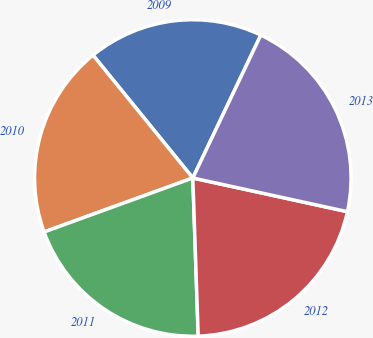Convert chart to OTSL. <chart><loc_0><loc_0><loc_500><loc_500><pie_chart><fcel>2009<fcel>2010<fcel>2011<fcel>2012<fcel>2013<nl><fcel>17.93%<fcel>19.68%<fcel>20.0%<fcel>21.04%<fcel>21.35%<nl></chart> 